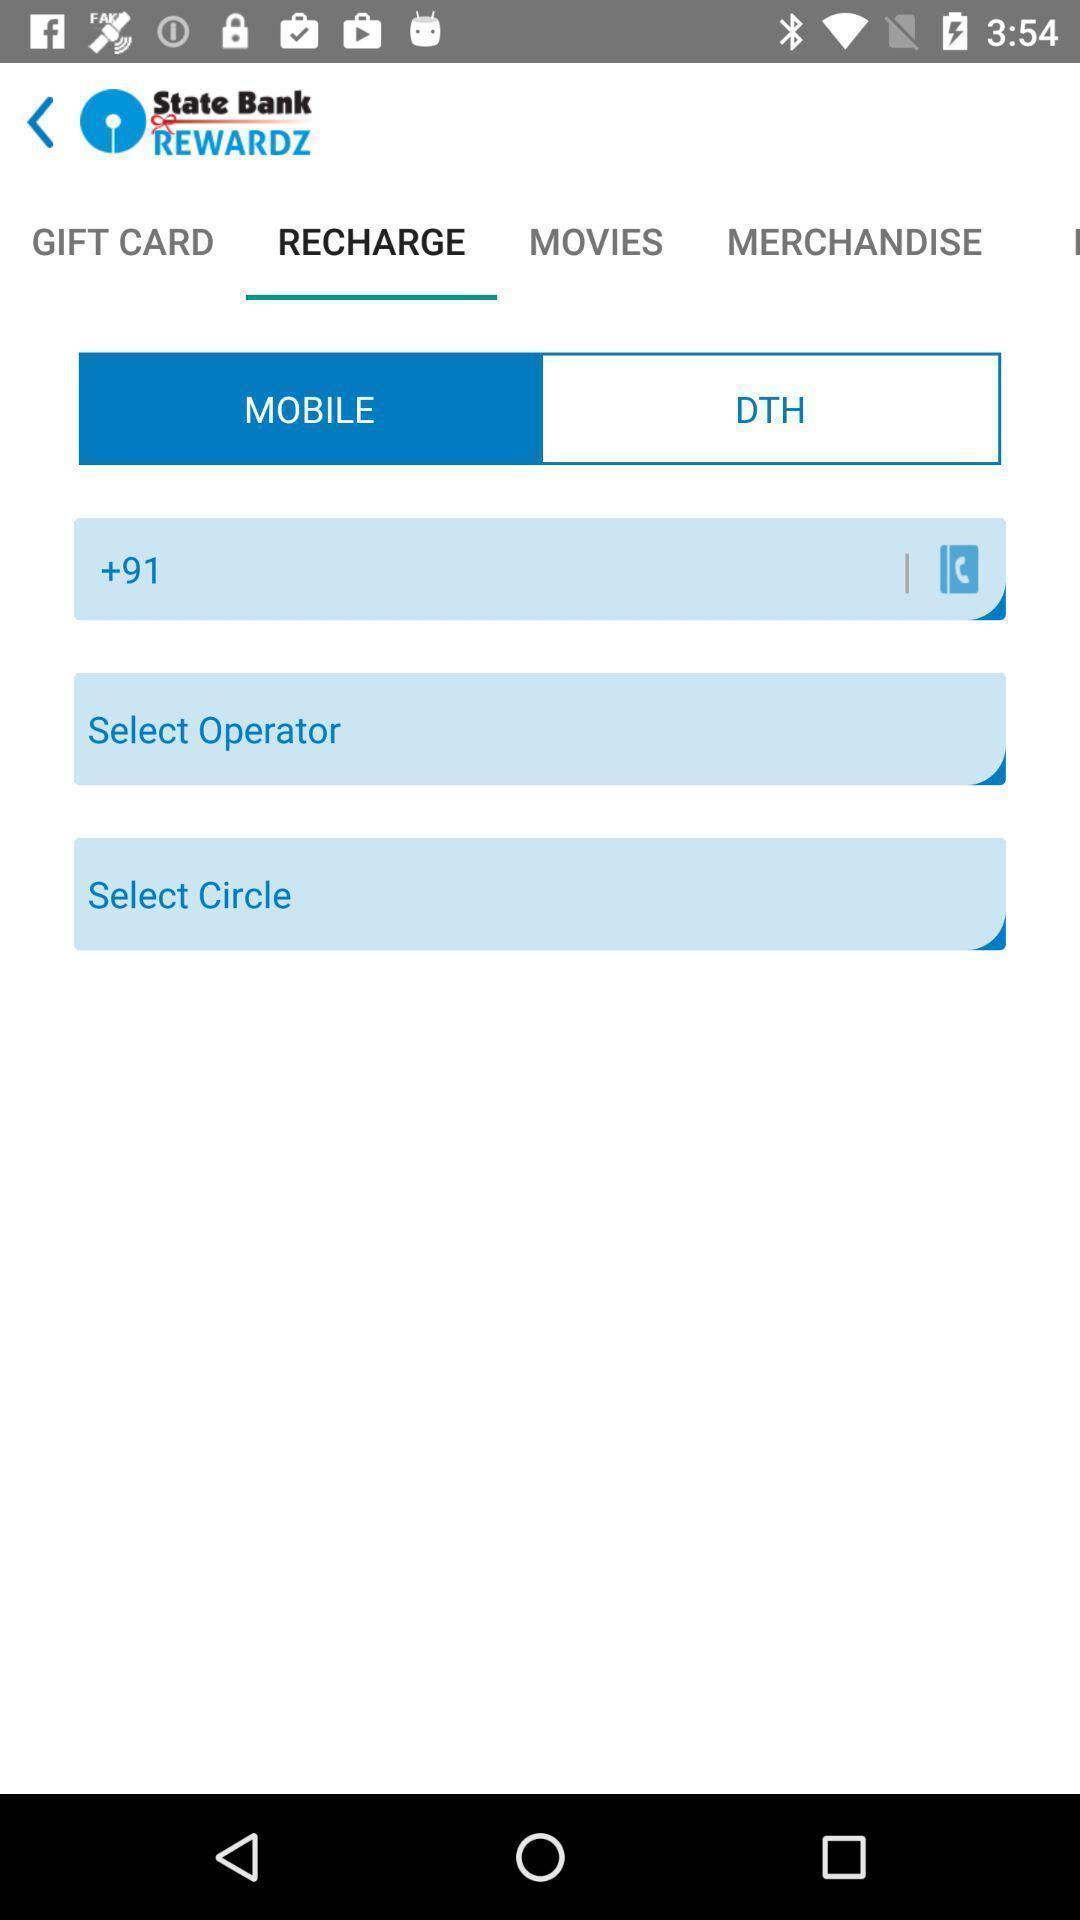Tell me about the visual elements in this screen capture. Screen displaying multiple options in mobile recharge page. 